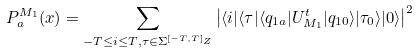Convert formula to latex. <formula><loc_0><loc_0><loc_500><loc_500>P _ { a } ^ { M _ { 1 } } ( x ) = \sum _ { - T \leq i \leq T , \tau \in \Sigma ^ { [ - T , T ] _ { Z } } } \left | \langle i | \langle \tau | \langle q _ { 1 a } | U _ { M _ { 1 } } ^ { t } | q _ { 1 0 } \rangle | \tau _ { 0 } \rangle | 0 \rangle \right | ^ { 2 }</formula> 